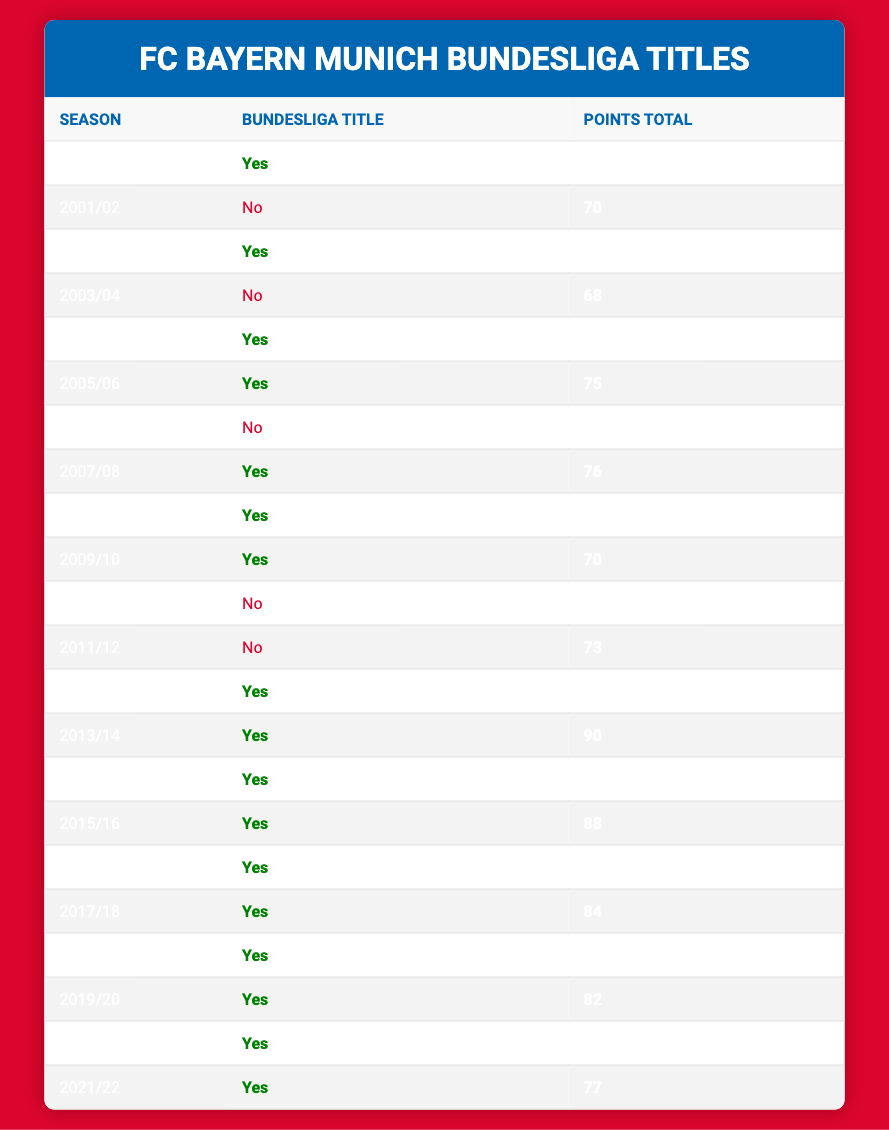What seasons did Bayern Munich win the Bundesliga title? The table lists seasons alongside whether Bayern Munich won the title. By filtering for "Yes" in the Bundesliga Title column, we find the seasons: 2000/01, 2002/03, 2004/05, 2005/06, 2007/08, 2008/09, 2009/10, 2012/13, 2013/14, 2014/15, 2015/16, 2016/17, 2017/18, 2018/19, 2019/20, 2020/21, and 2021/22.
Answer: 2000/01, 2002/03, 2004/05, 2005/06, 2007/08, 2008/09, 2009/10, 2012/13, 2013/14, 2014/15, 2015/16, 2016/17, 2017/18, 2018/19, 2019/20, 2020/21, 2021/22 How many points did Bayern Munich achieve in the 2012/13 season? The table shows the points total for each season. Looking at the row for the 2012/13 season, it indicates that Bayern Munich achieved a points total of 91.
Answer: 91 What was the average points total in the seasons Bayern Munich did not win the title? To find the average points for seasons without a title, identify the relevant seasons and their points: 2001/02 (70), 2003/04 (68), 2006/07 (60), 2010/11 (65), 2011/12 (73). Sum these points: 70 + 68 + 60 + 65 + 73 = 336. There are 5 seasons, so average points = 336 / 5 = 67.2.
Answer: 67.2 Did Bayern Munich win the Bundesliga title in 2010/11? Checking the table, the 2010/11 season row shows "No" under the Bundesliga Title column, indicating they did not win that season.
Answer: No In how many seasons did Bayern Munich earn more than 80 points? Review the points totals for all seasons. The seasons where Bayern earned more than 80 points are: 2012/13 (91), 2013/14 (90), 2015/16 (88), 2016/17 (82), 2017/18 (84), 2019/20 (82), 2020/21 (78) cannot exceed. In total, this gives 6 seasons with more than 80 points.
Answer: 6 